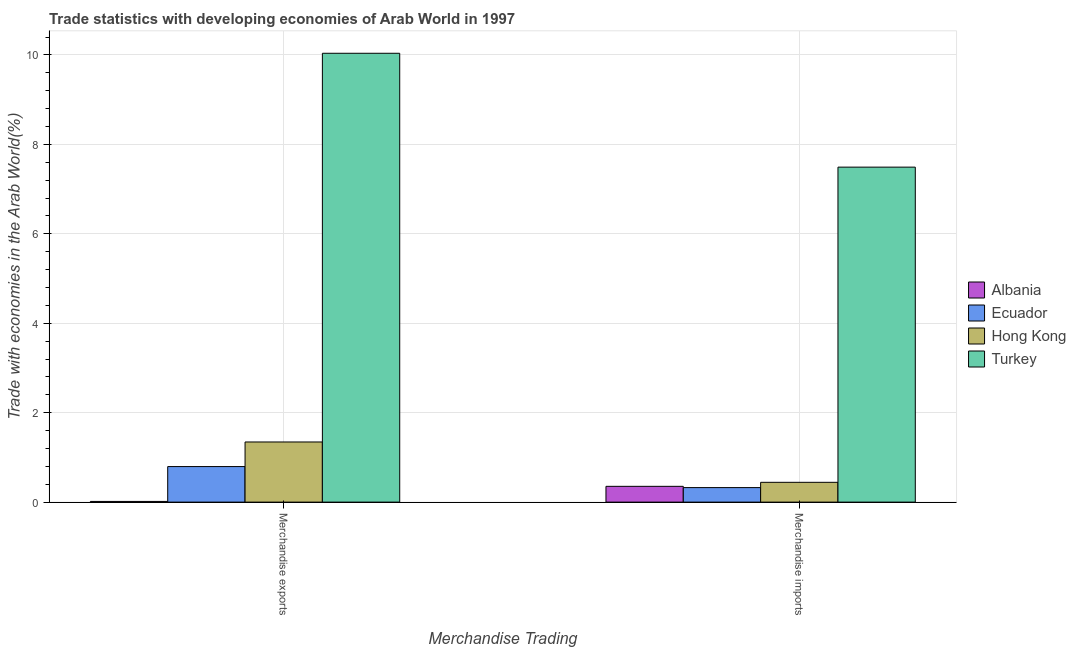Are the number of bars per tick equal to the number of legend labels?
Provide a short and direct response. Yes. How many bars are there on the 1st tick from the right?
Your answer should be compact. 4. What is the merchandise exports in Turkey?
Offer a terse response. 10.04. Across all countries, what is the maximum merchandise exports?
Keep it short and to the point. 10.04. Across all countries, what is the minimum merchandise exports?
Give a very brief answer. 0.02. In which country was the merchandise exports maximum?
Offer a terse response. Turkey. In which country was the merchandise exports minimum?
Your answer should be compact. Albania. What is the total merchandise exports in the graph?
Make the answer very short. 12.19. What is the difference between the merchandise imports in Hong Kong and that in Ecuador?
Your response must be concise. 0.12. What is the difference between the merchandise imports in Turkey and the merchandise exports in Ecuador?
Give a very brief answer. 6.7. What is the average merchandise exports per country?
Your answer should be very brief. 3.05. What is the difference between the merchandise exports and merchandise imports in Turkey?
Your response must be concise. 2.55. What is the ratio of the merchandise exports in Turkey to that in Ecuador?
Your answer should be very brief. 12.63. In how many countries, is the merchandise exports greater than the average merchandise exports taken over all countries?
Give a very brief answer. 1. What does the 2nd bar from the left in Merchandise imports represents?
Your answer should be very brief. Ecuador. What does the 3rd bar from the right in Merchandise imports represents?
Offer a terse response. Ecuador. How many bars are there?
Make the answer very short. 8. What is the difference between two consecutive major ticks on the Y-axis?
Provide a succinct answer. 2. Are the values on the major ticks of Y-axis written in scientific E-notation?
Offer a terse response. No. Does the graph contain grids?
Ensure brevity in your answer.  Yes. What is the title of the graph?
Your response must be concise. Trade statistics with developing economies of Arab World in 1997. Does "Armenia" appear as one of the legend labels in the graph?
Your answer should be compact. No. What is the label or title of the X-axis?
Give a very brief answer. Merchandise Trading. What is the label or title of the Y-axis?
Offer a terse response. Trade with economies in the Arab World(%). What is the Trade with economies in the Arab World(%) of Albania in Merchandise exports?
Ensure brevity in your answer.  0.02. What is the Trade with economies in the Arab World(%) in Ecuador in Merchandise exports?
Offer a terse response. 0.79. What is the Trade with economies in the Arab World(%) of Hong Kong in Merchandise exports?
Keep it short and to the point. 1.34. What is the Trade with economies in the Arab World(%) in Turkey in Merchandise exports?
Ensure brevity in your answer.  10.04. What is the Trade with economies in the Arab World(%) of Albania in Merchandise imports?
Keep it short and to the point. 0.35. What is the Trade with economies in the Arab World(%) in Ecuador in Merchandise imports?
Make the answer very short. 0.32. What is the Trade with economies in the Arab World(%) of Hong Kong in Merchandise imports?
Make the answer very short. 0.44. What is the Trade with economies in the Arab World(%) in Turkey in Merchandise imports?
Keep it short and to the point. 7.49. Across all Merchandise Trading, what is the maximum Trade with economies in the Arab World(%) of Albania?
Provide a short and direct response. 0.35. Across all Merchandise Trading, what is the maximum Trade with economies in the Arab World(%) of Ecuador?
Your answer should be very brief. 0.79. Across all Merchandise Trading, what is the maximum Trade with economies in the Arab World(%) in Hong Kong?
Your answer should be compact. 1.34. Across all Merchandise Trading, what is the maximum Trade with economies in the Arab World(%) in Turkey?
Provide a succinct answer. 10.04. Across all Merchandise Trading, what is the minimum Trade with economies in the Arab World(%) in Albania?
Give a very brief answer. 0.02. Across all Merchandise Trading, what is the minimum Trade with economies in the Arab World(%) in Ecuador?
Provide a short and direct response. 0.32. Across all Merchandise Trading, what is the minimum Trade with economies in the Arab World(%) in Hong Kong?
Your response must be concise. 0.44. Across all Merchandise Trading, what is the minimum Trade with economies in the Arab World(%) in Turkey?
Make the answer very short. 7.49. What is the total Trade with economies in the Arab World(%) in Albania in the graph?
Offer a very short reply. 0.37. What is the total Trade with economies in the Arab World(%) of Ecuador in the graph?
Offer a terse response. 1.12. What is the total Trade with economies in the Arab World(%) in Hong Kong in the graph?
Offer a very short reply. 1.79. What is the total Trade with economies in the Arab World(%) in Turkey in the graph?
Offer a very short reply. 17.53. What is the difference between the Trade with economies in the Arab World(%) of Albania in Merchandise exports and that in Merchandise imports?
Offer a very short reply. -0.34. What is the difference between the Trade with economies in the Arab World(%) in Ecuador in Merchandise exports and that in Merchandise imports?
Offer a very short reply. 0.47. What is the difference between the Trade with economies in the Arab World(%) in Hong Kong in Merchandise exports and that in Merchandise imports?
Offer a terse response. 0.9. What is the difference between the Trade with economies in the Arab World(%) in Turkey in Merchandise exports and that in Merchandise imports?
Offer a very short reply. 2.55. What is the difference between the Trade with economies in the Arab World(%) in Albania in Merchandise exports and the Trade with economies in the Arab World(%) in Ecuador in Merchandise imports?
Your answer should be very brief. -0.31. What is the difference between the Trade with economies in the Arab World(%) of Albania in Merchandise exports and the Trade with economies in the Arab World(%) of Hong Kong in Merchandise imports?
Offer a very short reply. -0.43. What is the difference between the Trade with economies in the Arab World(%) in Albania in Merchandise exports and the Trade with economies in the Arab World(%) in Turkey in Merchandise imports?
Your answer should be compact. -7.48. What is the difference between the Trade with economies in the Arab World(%) of Ecuador in Merchandise exports and the Trade with economies in the Arab World(%) of Hong Kong in Merchandise imports?
Make the answer very short. 0.35. What is the difference between the Trade with economies in the Arab World(%) of Ecuador in Merchandise exports and the Trade with economies in the Arab World(%) of Turkey in Merchandise imports?
Give a very brief answer. -6.7. What is the difference between the Trade with economies in the Arab World(%) of Hong Kong in Merchandise exports and the Trade with economies in the Arab World(%) of Turkey in Merchandise imports?
Your answer should be very brief. -6.15. What is the average Trade with economies in the Arab World(%) of Albania per Merchandise Trading?
Give a very brief answer. 0.18. What is the average Trade with economies in the Arab World(%) in Ecuador per Merchandise Trading?
Your answer should be very brief. 0.56. What is the average Trade with economies in the Arab World(%) of Hong Kong per Merchandise Trading?
Give a very brief answer. 0.89. What is the average Trade with economies in the Arab World(%) of Turkey per Merchandise Trading?
Your answer should be compact. 8.76. What is the difference between the Trade with economies in the Arab World(%) in Albania and Trade with economies in the Arab World(%) in Ecuador in Merchandise exports?
Make the answer very short. -0.78. What is the difference between the Trade with economies in the Arab World(%) in Albania and Trade with economies in the Arab World(%) in Hong Kong in Merchandise exports?
Offer a very short reply. -1.33. What is the difference between the Trade with economies in the Arab World(%) in Albania and Trade with economies in the Arab World(%) in Turkey in Merchandise exports?
Offer a terse response. -10.02. What is the difference between the Trade with economies in the Arab World(%) in Ecuador and Trade with economies in the Arab World(%) in Hong Kong in Merchandise exports?
Make the answer very short. -0.55. What is the difference between the Trade with economies in the Arab World(%) of Ecuador and Trade with economies in the Arab World(%) of Turkey in Merchandise exports?
Provide a succinct answer. -9.24. What is the difference between the Trade with economies in the Arab World(%) in Hong Kong and Trade with economies in the Arab World(%) in Turkey in Merchandise exports?
Offer a very short reply. -8.69. What is the difference between the Trade with economies in the Arab World(%) of Albania and Trade with economies in the Arab World(%) of Ecuador in Merchandise imports?
Keep it short and to the point. 0.03. What is the difference between the Trade with economies in the Arab World(%) of Albania and Trade with economies in the Arab World(%) of Hong Kong in Merchandise imports?
Provide a succinct answer. -0.09. What is the difference between the Trade with economies in the Arab World(%) of Albania and Trade with economies in the Arab World(%) of Turkey in Merchandise imports?
Ensure brevity in your answer.  -7.14. What is the difference between the Trade with economies in the Arab World(%) in Ecuador and Trade with economies in the Arab World(%) in Hong Kong in Merchandise imports?
Provide a succinct answer. -0.12. What is the difference between the Trade with economies in the Arab World(%) of Ecuador and Trade with economies in the Arab World(%) of Turkey in Merchandise imports?
Ensure brevity in your answer.  -7.17. What is the difference between the Trade with economies in the Arab World(%) of Hong Kong and Trade with economies in the Arab World(%) of Turkey in Merchandise imports?
Keep it short and to the point. -7.05. What is the ratio of the Trade with economies in the Arab World(%) in Albania in Merchandise exports to that in Merchandise imports?
Make the answer very short. 0.04. What is the ratio of the Trade with economies in the Arab World(%) of Ecuador in Merchandise exports to that in Merchandise imports?
Give a very brief answer. 2.45. What is the ratio of the Trade with economies in the Arab World(%) of Hong Kong in Merchandise exports to that in Merchandise imports?
Provide a succinct answer. 3.04. What is the ratio of the Trade with economies in the Arab World(%) in Turkey in Merchandise exports to that in Merchandise imports?
Provide a succinct answer. 1.34. What is the difference between the highest and the second highest Trade with economies in the Arab World(%) of Albania?
Your response must be concise. 0.34. What is the difference between the highest and the second highest Trade with economies in the Arab World(%) in Ecuador?
Give a very brief answer. 0.47. What is the difference between the highest and the second highest Trade with economies in the Arab World(%) of Hong Kong?
Make the answer very short. 0.9. What is the difference between the highest and the second highest Trade with economies in the Arab World(%) in Turkey?
Ensure brevity in your answer.  2.55. What is the difference between the highest and the lowest Trade with economies in the Arab World(%) in Albania?
Offer a very short reply. 0.34. What is the difference between the highest and the lowest Trade with economies in the Arab World(%) of Ecuador?
Give a very brief answer. 0.47. What is the difference between the highest and the lowest Trade with economies in the Arab World(%) of Hong Kong?
Your response must be concise. 0.9. What is the difference between the highest and the lowest Trade with economies in the Arab World(%) of Turkey?
Your answer should be compact. 2.55. 